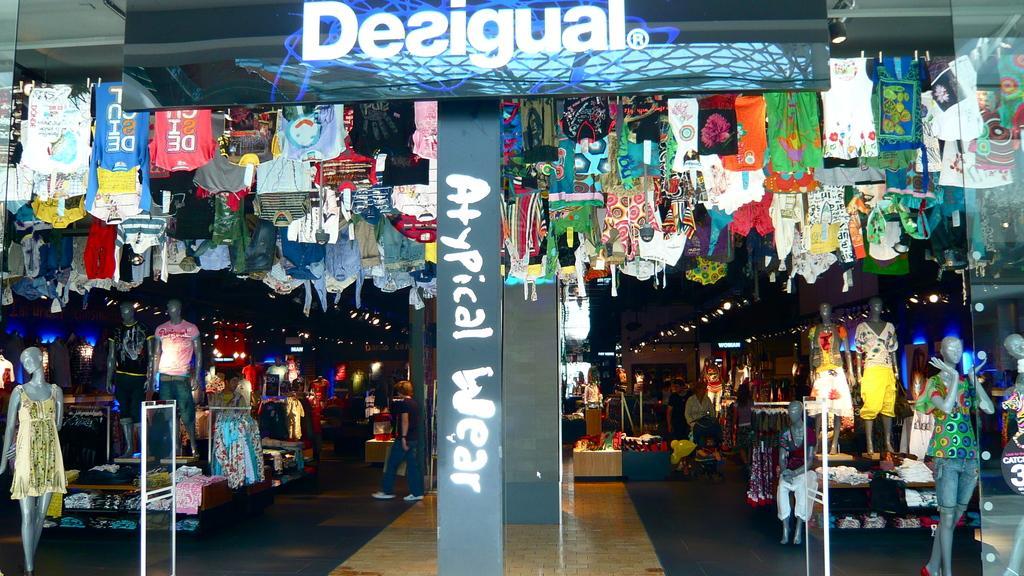How would you summarize this image in a sentence or two? As we can see in the image there is a banner, clothes, a person walking over here and there are statues. 